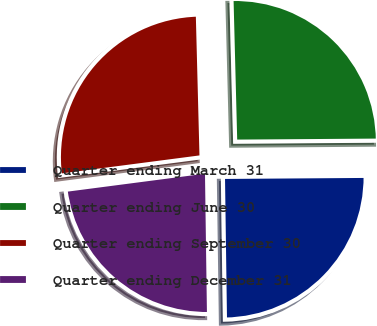<chart> <loc_0><loc_0><loc_500><loc_500><pie_chart><fcel>Quarter ending March 31<fcel>Quarter ending June 30<fcel>Quarter ending September 30<fcel>Quarter ending December 31<nl><fcel>24.89%<fcel>25.3%<fcel>26.65%<fcel>23.16%<nl></chart> 